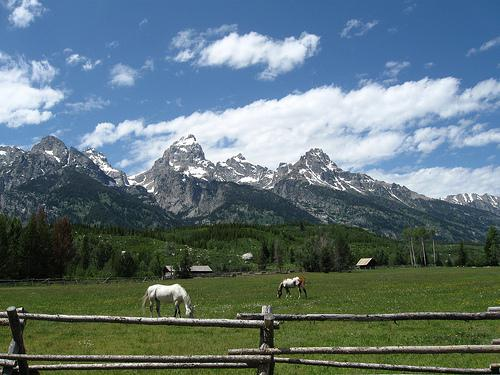Question: why is the photo clear?
Choices:
A. A good photographer.
B. It's during the day.
C. Had great  lighting.
D. It's a good picture.
Answer with the letter. Answer: B Question: what color is the grass?
Choices:
A. Blue.
B. Green.
C. Yellow.
D. Brown.
Answer with the letter. Answer: B Question: how is the weather?
Choices:
A. Raining.
B. Clear.
C. Middle of a tornado.
D. Sunny.
Answer with the letter. Answer: B Question: what are the horses eating?
Choices:
A. Oats.
B. Grain.
C. Grass.
D. Carrots.
Answer with the letter. Answer: C Question: where was the photo taken?
Choices:
A. Ski lodge.
B. Beach.
C. In a pasture.
D. School.
Answer with the letter. Answer: C 